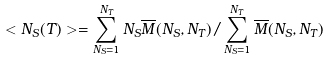<formula> <loc_0><loc_0><loc_500><loc_500>< N _ { S } ( T ) > = \sum _ { N _ { S } = 1 } ^ { N _ { T } } N _ { S } \overline { M } ( N _ { S } , N _ { T } ) / \sum _ { N _ { S } = 1 } ^ { N _ { T } } \overline { M } ( N _ { S } , N _ { T } )</formula> 